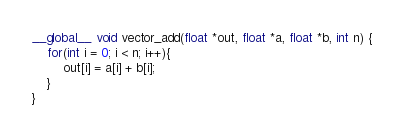Convert code to text. <code><loc_0><loc_0><loc_500><loc_500><_Cuda_>__global__ void vector_add(float *out, float *a, float *b, int n) {
    for(int i = 0; i < n; i++){
        out[i] = a[i] + b[i];
    }
}</code> 